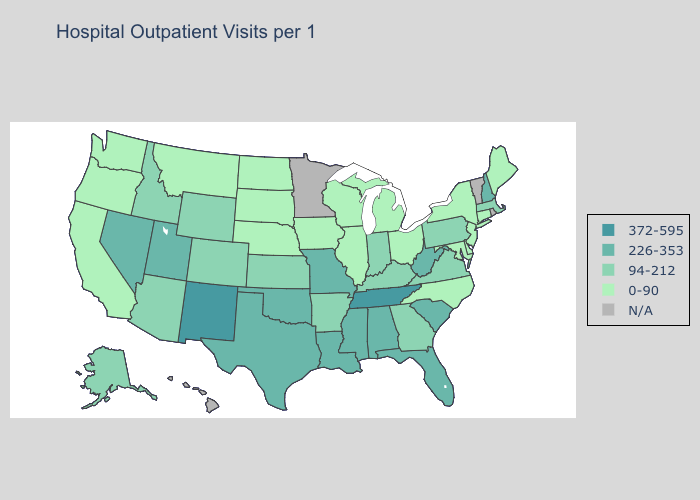Among the states that border Rhode Island , does Massachusetts have the highest value?
Be succinct. Yes. Which states have the highest value in the USA?
Keep it brief. New Mexico, Tennessee. Does Maryland have the lowest value in the South?
Short answer required. Yes. What is the value of Virginia?
Keep it brief. 94-212. What is the value of North Dakota?
Quick response, please. 0-90. What is the value of New Mexico?
Keep it brief. 372-595. Which states have the highest value in the USA?
Answer briefly. New Mexico, Tennessee. Among the states that border Oklahoma , which have the highest value?
Be succinct. New Mexico. Name the states that have a value in the range N/A?
Keep it brief. Hawaii, Minnesota, Rhode Island, Vermont. Among the states that border Tennessee , which have the highest value?
Be succinct. Alabama, Mississippi, Missouri. What is the lowest value in the USA?
Keep it brief. 0-90. What is the highest value in states that border Iowa?
Quick response, please. 226-353. Which states have the highest value in the USA?
Be succinct. New Mexico, Tennessee. Which states hav the highest value in the MidWest?
Be succinct. Missouri. 